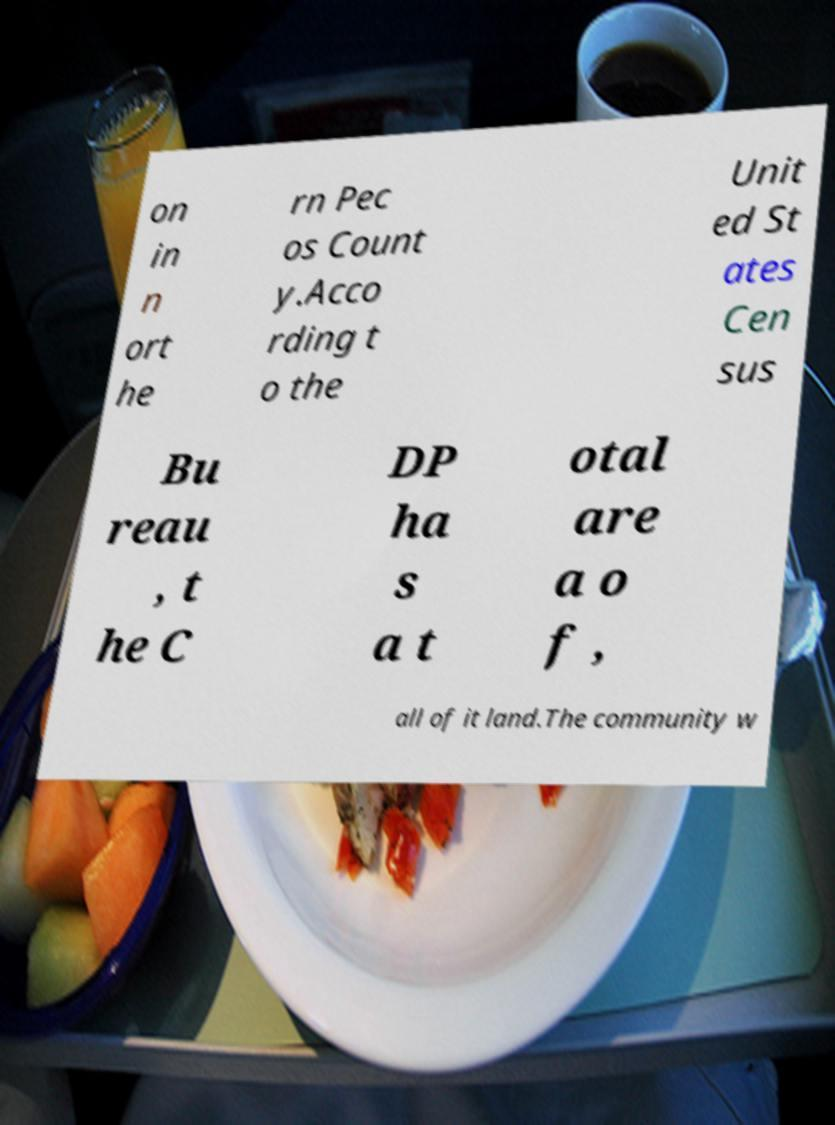Can you accurately transcribe the text from the provided image for me? on in n ort he rn Pec os Count y.Acco rding t o the Unit ed St ates Cen sus Bu reau , t he C DP ha s a t otal are a o f , all of it land.The community w 